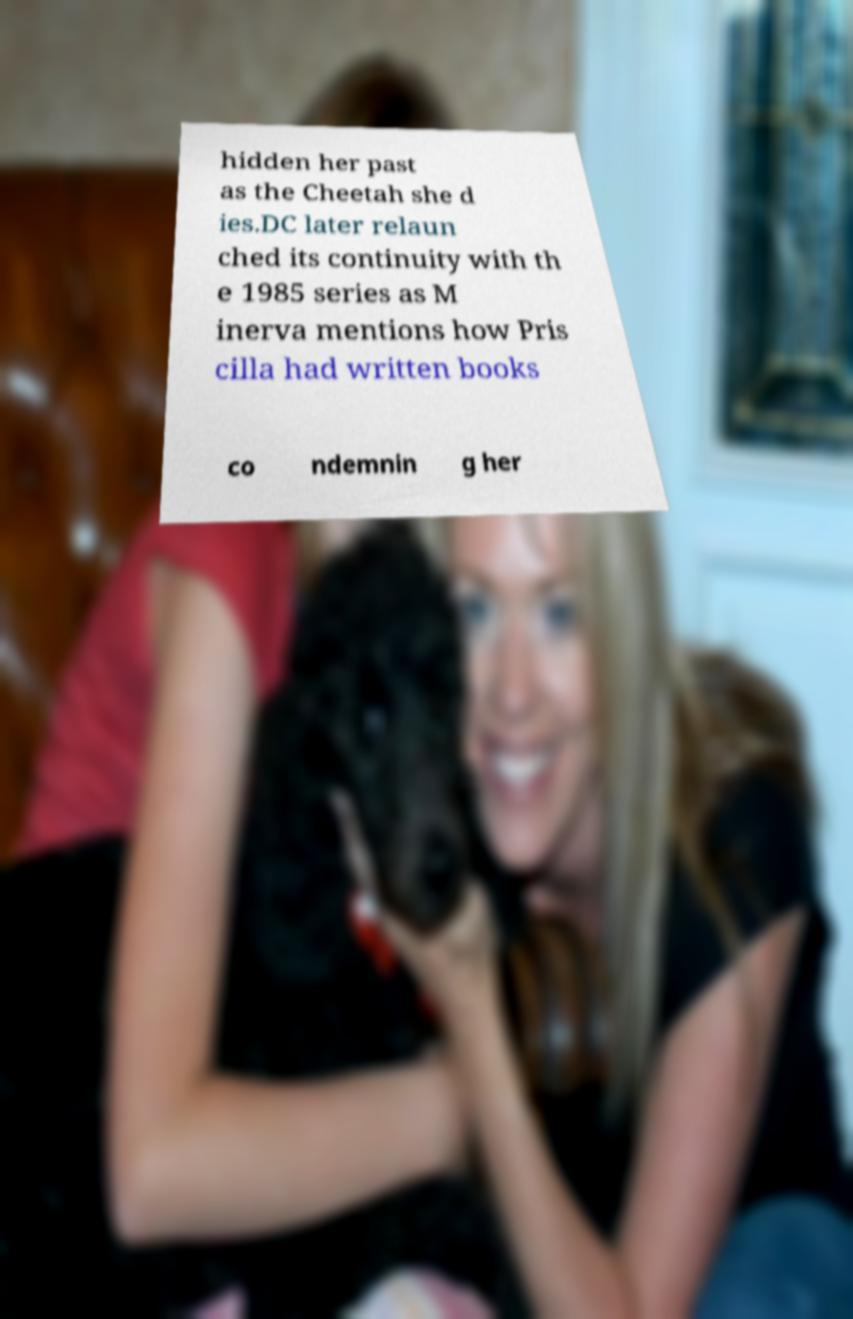Could you assist in decoding the text presented in this image and type it out clearly? hidden her past as the Cheetah she d ies.DC later relaun ched its continuity with th e 1985 series as M inerva mentions how Pris cilla had written books co ndemnin g her 